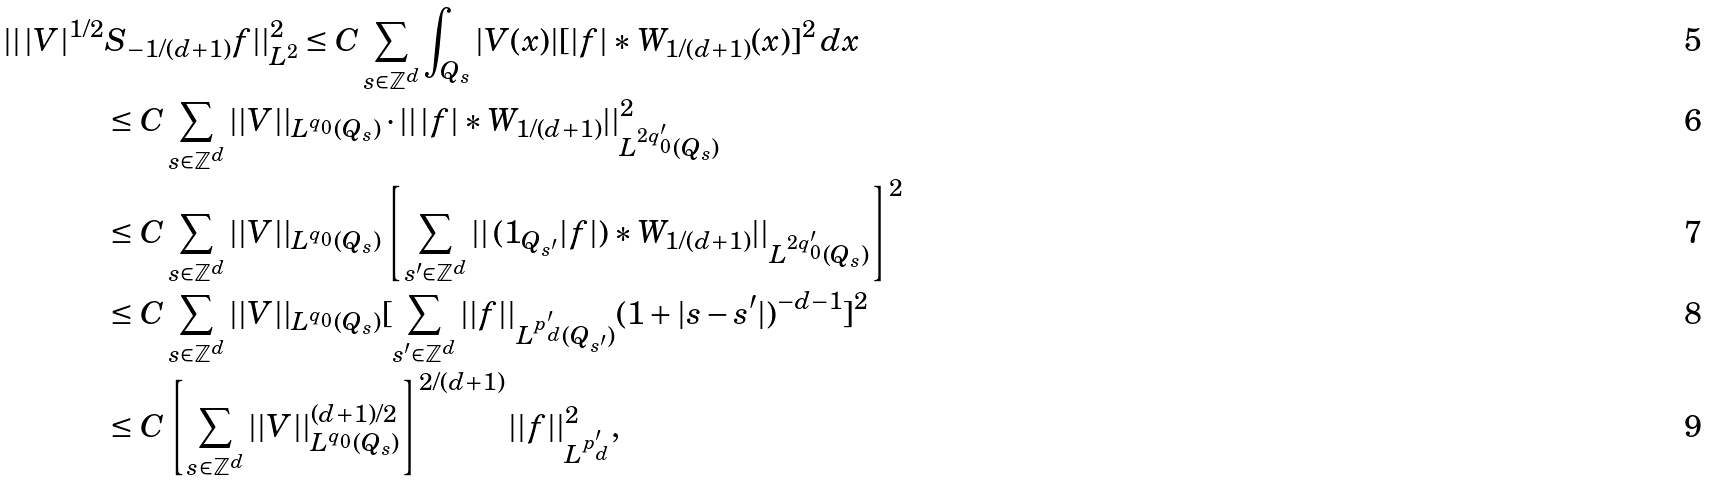<formula> <loc_0><loc_0><loc_500><loc_500>| | \, | V | ^ { 1 / 2 } & S _ { - 1 / ( d + 1 ) } f | | _ { L ^ { 2 } } ^ { 2 } \leq C \sum _ { s \in \mathbb { Z } ^ { d } } \int _ { Q _ { s } } | V ( x ) | [ | f | \ast W _ { 1 / ( d + 1 ) } ( x ) ] ^ { 2 } \, d x \\ & \leq C \sum _ { s \in \mathbb { Z } ^ { d } } | | V | | _ { L ^ { q _ { 0 } } ( Q _ { s } ) } \cdot | | \, | f | \ast W _ { 1 / ( d + 1 ) } | | _ { L ^ { 2 q _ { 0 } ^ { \prime } } ( Q _ { s } ) } ^ { 2 } \\ & \leq C \sum _ { s \in \mathbb { Z } ^ { d } } | | V | | _ { L ^ { q _ { 0 } } ( Q _ { s } ) } \left [ \sum _ { s ^ { \prime } \in \mathbb { Z } ^ { d } } | | \, ( 1 _ { Q _ { s ^ { \prime } } } | f | ) \ast W _ { 1 / ( d + 1 ) } | | _ { L ^ { 2 q _ { 0 } ^ { \prime } } ( Q _ { s } ) } \right ] ^ { 2 } \\ & \leq C \sum _ { s \in \mathbb { Z } ^ { d } } | | V | | _ { L ^ { q _ { 0 } } ( Q _ { s } ) } [ \sum _ { s ^ { \prime } \in \mathbb { Z } ^ { d } } | | f | | _ { L ^ { p ^ { \prime } _ { d } } ( Q _ { s ^ { \prime } } ) } ( 1 + | s - s ^ { \prime } | ) ^ { - d - 1 } ] ^ { 2 } \\ & \leq C \left [ \sum _ { s \in \mathbb { Z } ^ { d } } | | V | | _ { L ^ { q _ { 0 } } ( Q _ { s } ) } ^ { ( d + 1 ) / 2 } \right ] ^ { 2 / ( d + 1 ) } | | f | | _ { L ^ { p ^ { \prime } _ { d } } } ^ { 2 } ,</formula> 